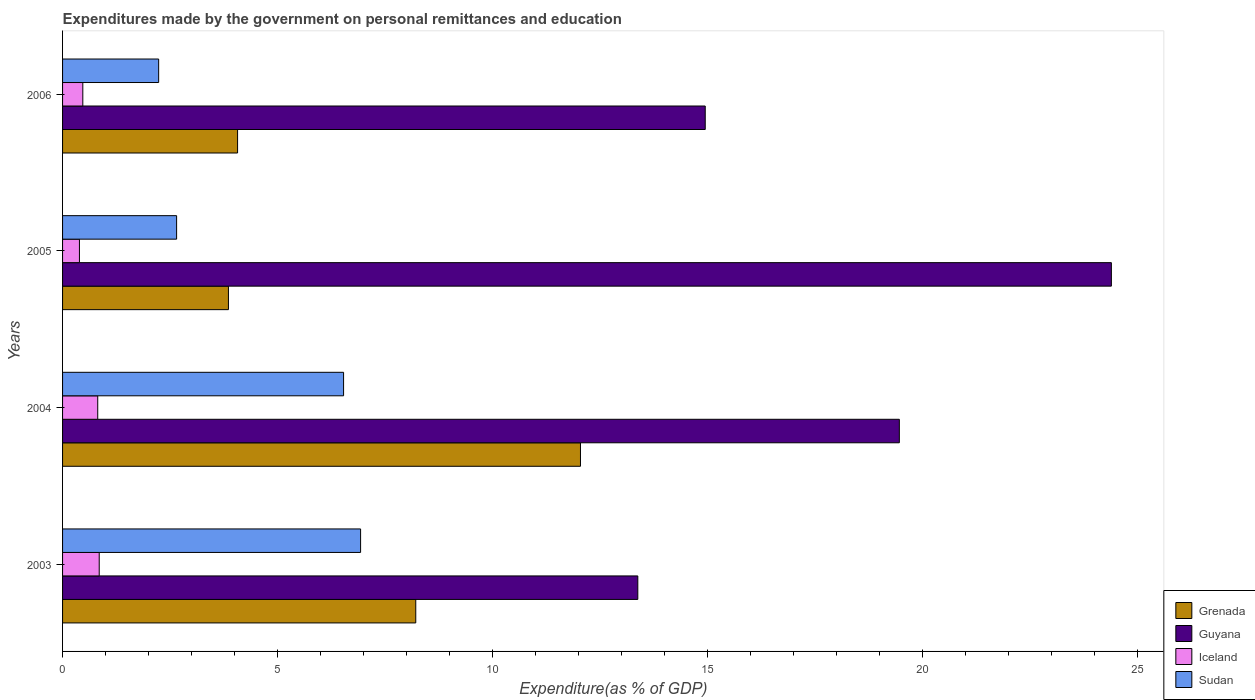How many bars are there on the 3rd tick from the top?
Provide a short and direct response. 4. How many bars are there on the 3rd tick from the bottom?
Keep it short and to the point. 4. In how many cases, is the number of bars for a given year not equal to the number of legend labels?
Offer a terse response. 0. What is the expenditures made by the government on personal remittances and education in Iceland in 2004?
Ensure brevity in your answer.  0.82. Across all years, what is the maximum expenditures made by the government on personal remittances and education in Guyana?
Provide a succinct answer. 24.4. Across all years, what is the minimum expenditures made by the government on personal remittances and education in Guyana?
Make the answer very short. 13.38. In which year was the expenditures made by the government on personal remittances and education in Guyana maximum?
Your response must be concise. 2005. What is the total expenditures made by the government on personal remittances and education in Grenada in the graph?
Provide a short and direct response. 28.2. What is the difference between the expenditures made by the government on personal remittances and education in Guyana in 2005 and that in 2006?
Make the answer very short. 9.45. What is the difference between the expenditures made by the government on personal remittances and education in Sudan in 2004 and the expenditures made by the government on personal remittances and education in Grenada in 2006?
Offer a very short reply. 2.47. What is the average expenditures made by the government on personal remittances and education in Sudan per year?
Ensure brevity in your answer.  4.59. In the year 2006, what is the difference between the expenditures made by the government on personal remittances and education in Grenada and expenditures made by the government on personal remittances and education in Sudan?
Provide a short and direct response. 1.84. What is the ratio of the expenditures made by the government on personal remittances and education in Grenada in 2004 to that in 2006?
Keep it short and to the point. 2.96. Is the expenditures made by the government on personal remittances and education in Iceland in 2003 less than that in 2004?
Ensure brevity in your answer.  No. What is the difference between the highest and the second highest expenditures made by the government on personal remittances and education in Iceland?
Make the answer very short. 0.03. What is the difference between the highest and the lowest expenditures made by the government on personal remittances and education in Iceland?
Keep it short and to the point. 0.46. Is it the case that in every year, the sum of the expenditures made by the government on personal remittances and education in Sudan and expenditures made by the government on personal remittances and education in Guyana is greater than the sum of expenditures made by the government on personal remittances and education in Grenada and expenditures made by the government on personal remittances and education in Iceland?
Offer a terse response. Yes. What does the 4th bar from the top in 2003 represents?
Offer a very short reply. Grenada. Is it the case that in every year, the sum of the expenditures made by the government on personal remittances and education in Guyana and expenditures made by the government on personal remittances and education in Sudan is greater than the expenditures made by the government on personal remittances and education in Iceland?
Provide a succinct answer. Yes. How many bars are there?
Provide a succinct answer. 16. How many years are there in the graph?
Offer a terse response. 4. What is the difference between two consecutive major ticks on the X-axis?
Your response must be concise. 5. Does the graph contain grids?
Keep it short and to the point. No. How many legend labels are there?
Your answer should be compact. 4. What is the title of the graph?
Give a very brief answer. Expenditures made by the government on personal remittances and education. What is the label or title of the X-axis?
Your response must be concise. Expenditure(as % of GDP). What is the Expenditure(as % of GDP) of Grenada in 2003?
Give a very brief answer. 8.22. What is the Expenditure(as % of GDP) of Guyana in 2003?
Keep it short and to the point. 13.38. What is the Expenditure(as % of GDP) in Iceland in 2003?
Your answer should be very brief. 0.85. What is the Expenditure(as % of GDP) in Sudan in 2003?
Your answer should be very brief. 6.93. What is the Expenditure(as % of GDP) in Grenada in 2004?
Keep it short and to the point. 12.05. What is the Expenditure(as % of GDP) in Guyana in 2004?
Provide a succinct answer. 19.47. What is the Expenditure(as % of GDP) of Iceland in 2004?
Make the answer very short. 0.82. What is the Expenditure(as % of GDP) of Sudan in 2004?
Make the answer very short. 6.54. What is the Expenditure(as % of GDP) in Grenada in 2005?
Give a very brief answer. 3.86. What is the Expenditure(as % of GDP) in Guyana in 2005?
Ensure brevity in your answer.  24.4. What is the Expenditure(as % of GDP) in Iceland in 2005?
Your response must be concise. 0.39. What is the Expenditure(as % of GDP) in Sudan in 2005?
Ensure brevity in your answer.  2.65. What is the Expenditure(as % of GDP) in Grenada in 2006?
Ensure brevity in your answer.  4.07. What is the Expenditure(as % of GDP) in Guyana in 2006?
Offer a very short reply. 14.95. What is the Expenditure(as % of GDP) of Iceland in 2006?
Your answer should be compact. 0.47. What is the Expenditure(as % of GDP) of Sudan in 2006?
Give a very brief answer. 2.24. Across all years, what is the maximum Expenditure(as % of GDP) of Grenada?
Make the answer very short. 12.05. Across all years, what is the maximum Expenditure(as % of GDP) in Guyana?
Give a very brief answer. 24.4. Across all years, what is the maximum Expenditure(as % of GDP) in Iceland?
Make the answer very short. 0.85. Across all years, what is the maximum Expenditure(as % of GDP) of Sudan?
Ensure brevity in your answer.  6.93. Across all years, what is the minimum Expenditure(as % of GDP) in Grenada?
Your response must be concise. 3.86. Across all years, what is the minimum Expenditure(as % of GDP) in Guyana?
Your answer should be compact. 13.38. Across all years, what is the minimum Expenditure(as % of GDP) of Iceland?
Your response must be concise. 0.39. Across all years, what is the minimum Expenditure(as % of GDP) in Sudan?
Provide a succinct answer. 2.24. What is the total Expenditure(as % of GDP) of Grenada in the graph?
Offer a very short reply. 28.2. What is the total Expenditure(as % of GDP) of Guyana in the graph?
Your answer should be very brief. 72.21. What is the total Expenditure(as % of GDP) of Iceland in the graph?
Keep it short and to the point. 2.53. What is the total Expenditure(as % of GDP) in Sudan in the graph?
Offer a terse response. 18.36. What is the difference between the Expenditure(as % of GDP) in Grenada in 2003 and that in 2004?
Offer a very short reply. -3.83. What is the difference between the Expenditure(as % of GDP) in Guyana in 2003 and that in 2004?
Your response must be concise. -6.08. What is the difference between the Expenditure(as % of GDP) of Iceland in 2003 and that in 2004?
Offer a terse response. 0.03. What is the difference between the Expenditure(as % of GDP) of Sudan in 2003 and that in 2004?
Your answer should be very brief. 0.4. What is the difference between the Expenditure(as % of GDP) of Grenada in 2003 and that in 2005?
Provide a short and direct response. 4.36. What is the difference between the Expenditure(as % of GDP) of Guyana in 2003 and that in 2005?
Make the answer very short. -11.02. What is the difference between the Expenditure(as % of GDP) of Iceland in 2003 and that in 2005?
Make the answer very short. 0.46. What is the difference between the Expenditure(as % of GDP) in Sudan in 2003 and that in 2005?
Your answer should be compact. 4.28. What is the difference between the Expenditure(as % of GDP) of Grenada in 2003 and that in 2006?
Provide a succinct answer. 4.15. What is the difference between the Expenditure(as % of GDP) in Guyana in 2003 and that in 2006?
Ensure brevity in your answer.  -1.57. What is the difference between the Expenditure(as % of GDP) in Iceland in 2003 and that in 2006?
Provide a short and direct response. 0.38. What is the difference between the Expenditure(as % of GDP) in Sudan in 2003 and that in 2006?
Provide a succinct answer. 4.7. What is the difference between the Expenditure(as % of GDP) of Grenada in 2004 and that in 2005?
Your answer should be very brief. 8.19. What is the difference between the Expenditure(as % of GDP) in Guyana in 2004 and that in 2005?
Provide a short and direct response. -4.93. What is the difference between the Expenditure(as % of GDP) of Iceland in 2004 and that in 2005?
Your response must be concise. 0.43. What is the difference between the Expenditure(as % of GDP) of Sudan in 2004 and that in 2005?
Provide a succinct answer. 3.88. What is the difference between the Expenditure(as % of GDP) of Grenada in 2004 and that in 2006?
Offer a very short reply. 7.98. What is the difference between the Expenditure(as % of GDP) in Guyana in 2004 and that in 2006?
Your response must be concise. 4.52. What is the difference between the Expenditure(as % of GDP) in Iceland in 2004 and that in 2006?
Make the answer very short. 0.35. What is the difference between the Expenditure(as % of GDP) in Sudan in 2004 and that in 2006?
Provide a succinct answer. 4.3. What is the difference between the Expenditure(as % of GDP) in Grenada in 2005 and that in 2006?
Give a very brief answer. -0.21. What is the difference between the Expenditure(as % of GDP) of Guyana in 2005 and that in 2006?
Offer a very short reply. 9.45. What is the difference between the Expenditure(as % of GDP) of Iceland in 2005 and that in 2006?
Your response must be concise. -0.08. What is the difference between the Expenditure(as % of GDP) of Sudan in 2005 and that in 2006?
Ensure brevity in your answer.  0.42. What is the difference between the Expenditure(as % of GDP) of Grenada in 2003 and the Expenditure(as % of GDP) of Guyana in 2004?
Ensure brevity in your answer.  -11.25. What is the difference between the Expenditure(as % of GDP) of Grenada in 2003 and the Expenditure(as % of GDP) of Iceland in 2004?
Your answer should be compact. 7.4. What is the difference between the Expenditure(as % of GDP) of Grenada in 2003 and the Expenditure(as % of GDP) of Sudan in 2004?
Give a very brief answer. 1.68. What is the difference between the Expenditure(as % of GDP) of Guyana in 2003 and the Expenditure(as % of GDP) of Iceland in 2004?
Your response must be concise. 12.57. What is the difference between the Expenditure(as % of GDP) of Guyana in 2003 and the Expenditure(as % of GDP) of Sudan in 2004?
Make the answer very short. 6.85. What is the difference between the Expenditure(as % of GDP) in Iceland in 2003 and the Expenditure(as % of GDP) in Sudan in 2004?
Provide a succinct answer. -5.69. What is the difference between the Expenditure(as % of GDP) in Grenada in 2003 and the Expenditure(as % of GDP) in Guyana in 2005?
Make the answer very short. -16.18. What is the difference between the Expenditure(as % of GDP) of Grenada in 2003 and the Expenditure(as % of GDP) of Iceland in 2005?
Your response must be concise. 7.83. What is the difference between the Expenditure(as % of GDP) of Grenada in 2003 and the Expenditure(as % of GDP) of Sudan in 2005?
Provide a succinct answer. 5.56. What is the difference between the Expenditure(as % of GDP) in Guyana in 2003 and the Expenditure(as % of GDP) in Iceland in 2005?
Keep it short and to the point. 12.99. What is the difference between the Expenditure(as % of GDP) of Guyana in 2003 and the Expenditure(as % of GDP) of Sudan in 2005?
Your response must be concise. 10.73. What is the difference between the Expenditure(as % of GDP) in Iceland in 2003 and the Expenditure(as % of GDP) in Sudan in 2005?
Ensure brevity in your answer.  -1.8. What is the difference between the Expenditure(as % of GDP) in Grenada in 2003 and the Expenditure(as % of GDP) in Guyana in 2006?
Your answer should be compact. -6.74. What is the difference between the Expenditure(as % of GDP) of Grenada in 2003 and the Expenditure(as % of GDP) of Iceland in 2006?
Offer a terse response. 7.75. What is the difference between the Expenditure(as % of GDP) in Grenada in 2003 and the Expenditure(as % of GDP) in Sudan in 2006?
Your answer should be very brief. 5.98. What is the difference between the Expenditure(as % of GDP) in Guyana in 2003 and the Expenditure(as % of GDP) in Iceland in 2006?
Make the answer very short. 12.91. What is the difference between the Expenditure(as % of GDP) of Guyana in 2003 and the Expenditure(as % of GDP) of Sudan in 2006?
Your response must be concise. 11.15. What is the difference between the Expenditure(as % of GDP) in Iceland in 2003 and the Expenditure(as % of GDP) in Sudan in 2006?
Keep it short and to the point. -1.38. What is the difference between the Expenditure(as % of GDP) of Grenada in 2004 and the Expenditure(as % of GDP) of Guyana in 2005?
Ensure brevity in your answer.  -12.35. What is the difference between the Expenditure(as % of GDP) in Grenada in 2004 and the Expenditure(as % of GDP) in Iceland in 2005?
Your answer should be compact. 11.66. What is the difference between the Expenditure(as % of GDP) in Grenada in 2004 and the Expenditure(as % of GDP) in Sudan in 2005?
Ensure brevity in your answer.  9.4. What is the difference between the Expenditure(as % of GDP) of Guyana in 2004 and the Expenditure(as % of GDP) of Iceland in 2005?
Your answer should be very brief. 19.08. What is the difference between the Expenditure(as % of GDP) in Guyana in 2004 and the Expenditure(as % of GDP) in Sudan in 2005?
Give a very brief answer. 16.82. What is the difference between the Expenditure(as % of GDP) in Iceland in 2004 and the Expenditure(as % of GDP) in Sudan in 2005?
Your response must be concise. -1.84. What is the difference between the Expenditure(as % of GDP) of Grenada in 2004 and the Expenditure(as % of GDP) of Guyana in 2006?
Provide a succinct answer. -2.9. What is the difference between the Expenditure(as % of GDP) in Grenada in 2004 and the Expenditure(as % of GDP) in Iceland in 2006?
Offer a terse response. 11.58. What is the difference between the Expenditure(as % of GDP) in Grenada in 2004 and the Expenditure(as % of GDP) in Sudan in 2006?
Your response must be concise. 9.81. What is the difference between the Expenditure(as % of GDP) of Guyana in 2004 and the Expenditure(as % of GDP) of Iceland in 2006?
Provide a short and direct response. 19. What is the difference between the Expenditure(as % of GDP) of Guyana in 2004 and the Expenditure(as % of GDP) of Sudan in 2006?
Give a very brief answer. 17.23. What is the difference between the Expenditure(as % of GDP) of Iceland in 2004 and the Expenditure(as % of GDP) of Sudan in 2006?
Provide a succinct answer. -1.42. What is the difference between the Expenditure(as % of GDP) in Grenada in 2005 and the Expenditure(as % of GDP) in Guyana in 2006?
Provide a succinct answer. -11.09. What is the difference between the Expenditure(as % of GDP) in Grenada in 2005 and the Expenditure(as % of GDP) in Iceland in 2006?
Ensure brevity in your answer.  3.39. What is the difference between the Expenditure(as % of GDP) in Grenada in 2005 and the Expenditure(as % of GDP) in Sudan in 2006?
Provide a succinct answer. 1.62. What is the difference between the Expenditure(as % of GDP) in Guyana in 2005 and the Expenditure(as % of GDP) in Iceland in 2006?
Offer a very short reply. 23.93. What is the difference between the Expenditure(as % of GDP) of Guyana in 2005 and the Expenditure(as % of GDP) of Sudan in 2006?
Provide a succinct answer. 22.17. What is the difference between the Expenditure(as % of GDP) in Iceland in 2005 and the Expenditure(as % of GDP) in Sudan in 2006?
Give a very brief answer. -1.84. What is the average Expenditure(as % of GDP) in Grenada per year?
Provide a short and direct response. 7.05. What is the average Expenditure(as % of GDP) of Guyana per year?
Keep it short and to the point. 18.05. What is the average Expenditure(as % of GDP) of Iceland per year?
Your response must be concise. 0.63. What is the average Expenditure(as % of GDP) of Sudan per year?
Provide a short and direct response. 4.59. In the year 2003, what is the difference between the Expenditure(as % of GDP) in Grenada and Expenditure(as % of GDP) in Guyana?
Provide a short and direct response. -5.17. In the year 2003, what is the difference between the Expenditure(as % of GDP) of Grenada and Expenditure(as % of GDP) of Iceland?
Offer a terse response. 7.36. In the year 2003, what is the difference between the Expenditure(as % of GDP) of Grenada and Expenditure(as % of GDP) of Sudan?
Offer a very short reply. 1.28. In the year 2003, what is the difference between the Expenditure(as % of GDP) in Guyana and Expenditure(as % of GDP) in Iceland?
Your response must be concise. 12.53. In the year 2003, what is the difference between the Expenditure(as % of GDP) of Guyana and Expenditure(as % of GDP) of Sudan?
Your answer should be compact. 6.45. In the year 2003, what is the difference between the Expenditure(as % of GDP) in Iceland and Expenditure(as % of GDP) in Sudan?
Ensure brevity in your answer.  -6.08. In the year 2004, what is the difference between the Expenditure(as % of GDP) of Grenada and Expenditure(as % of GDP) of Guyana?
Offer a very short reply. -7.42. In the year 2004, what is the difference between the Expenditure(as % of GDP) of Grenada and Expenditure(as % of GDP) of Iceland?
Your response must be concise. 11.23. In the year 2004, what is the difference between the Expenditure(as % of GDP) in Grenada and Expenditure(as % of GDP) in Sudan?
Offer a terse response. 5.51. In the year 2004, what is the difference between the Expenditure(as % of GDP) of Guyana and Expenditure(as % of GDP) of Iceland?
Keep it short and to the point. 18.65. In the year 2004, what is the difference between the Expenditure(as % of GDP) of Guyana and Expenditure(as % of GDP) of Sudan?
Ensure brevity in your answer.  12.93. In the year 2004, what is the difference between the Expenditure(as % of GDP) in Iceland and Expenditure(as % of GDP) in Sudan?
Provide a succinct answer. -5.72. In the year 2005, what is the difference between the Expenditure(as % of GDP) in Grenada and Expenditure(as % of GDP) in Guyana?
Ensure brevity in your answer.  -20.54. In the year 2005, what is the difference between the Expenditure(as % of GDP) in Grenada and Expenditure(as % of GDP) in Iceland?
Offer a very short reply. 3.47. In the year 2005, what is the difference between the Expenditure(as % of GDP) in Grenada and Expenditure(as % of GDP) in Sudan?
Make the answer very short. 1.21. In the year 2005, what is the difference between the Expenditure(as % of GDP) in Guyana and Expenditure(as % of GDP) in Iceland?
Keep it short and to the point. 24.01. In the year 2005, what is the difference between the Expenditure(as % of GDP) in Guyana and Expenditure(as % of GDP) in Sudan?
Your answer should be compact. 21.75. In the year 2005, what is the difference between the Expenditure(as % of GDP) of Iceland and Expenditure(as % of GDP) of Sudan?
Offer a very short reply. -2.26. In the year 2006, what is the difference between the Expenditure(as % of GDP) of Grenada and Expenditure(as % of GDP) of Guyana?
Ensure brevity in your answer.  -10.88. In the year 2006, what is the difference between the Expenditure(as % of GDP) in Grenada and Expenditure(as % of GDP) in Iceland?
Your answer should be compact. 3.6. In the year 2006, what is the difference between the Expenditure(as % of GDP) of Grenada and Expenditure(as % of GDP) of Sudan?
Keep it short and to the point. 1.84. In the year 2006, what is the difference between the Expenditure(as % of GDP) in Guyana and Expenditure(as % of GDP) in Iceland?
Provide a succinct answer. 14.48. In the year 2006, what is the difference between the Expenditure(as % of GDP) in Guyana and Expenditure(as % of GDP) in Sudan?
Your answer should be compact. 12.72. In the year 2006, what is the difference between the Expenditure(as % of GDP) of Iceland and Expenditure(as % of GDP) of Sudan?
Keep it short and to the point. -1.76. What is the ratio of the Expenditure(as % of GDP) of Grenada in 2003 to that in 2004?
Ensure brevity in your answer.  0.68. What is the ratio of the Expenditure(as % of GDP) of Guyana in 2003 to that in 2004?
Offer a very short reply. 0.69. What is the ratio of the Expenditure(as % of GDP) in Iceland in 2003 to that in 2004?
Your response must be concise. 1.04. What is the ratio of the Expenditure(as % of GDP) in Sudan in 2003 to that in 2004?
Ensure brevity in your answer.  1.06. What is the ratio of the Expenditure(as % of GDP) of Grenada in 2003 to that in 2005?
Offer a very short reply. 2.13. What is the ratio of the Expenditure(as % of GDP) of Guyana in 2003 to that in 2005?
Ensure brevity in your answer.  0.55. What is the ratio of the Expenditure(as % of GDP) of Iceland in 2003 to that in 2005?
Give a very brief answer. 2.17. What is the ratio of the Expenditure(as % of GDP) in Sudan in 2003 to that in 2005?
Offer a terse response. 2.61. What is the ratio of the Expenditure(as % of GDP) of Grenada in 2003 to that in 2006?
Offer a terse response. 2.02. What is the ratio of the Expenditure(as % of GDP) in Guyana in 2003 to that in 2006?
Provide a succinct answer. 0.9. What is the ratio of the Expenditure(as % of GDP) of Iceland in 2003 to that in 2006?
Ensure brevity in your answer.  1.81. What is the ratio of the Expenditure(as % of GDP) of Sudan in 2003 to that in 2006?
Provide a short and direct response. 3.1. What is the ratio of the Expenditure(as % of GDP) in Grenada in 2004 to that in 2005?
Provide a succinct answer. 3.12. What is the ratio of the Expenditure(as % of GDP) of Guyana in 2004 to that in 2005?
Ensure brevity in your answer.  0.8. What is the ratio of the Expenditure(as % of GDP) in Iceland in 2004 to that in 2005?
Provide a succinct answer. 2.08. What is the ratio of the Expenditure(as % of GDP) of Sudan in 2004 to that in 2005?
Offer a very short reply. 2.46. What is the ratio of the Expenditure(as % of GDP) in Grenada in 2004 to that in 2006?
Your answer should be compact. 2.96. What is the ratio of the Expenditure(as % of GDP) of Guyana in 2004 to that in 2006?
Provide a short and direct response. 1.3. What is the ratio of the Expenditure(as % of GDP) in Iceland in 2004 to that in 2006?
Ensure brevity in your answer.  1.74. What is the ratio of the Expenditure(as % of GDP) in Sudan in 2004 to that in 2006?
Your answer should be very brief. 2.92. What is the ratio of the Expenditure(as % of GDP) in Grenada in 2005 to that in 2006?
Your answer should be very brief. 0.95. What is the ratio of the Expenditure(as % of GDP) of Guyana in 2005 to that in 2006?
Keep it short and to the point. 1.63. What is the ratio of the Expenditure(as % of GDP) in Iceland in 2005 to that in 2006?
Your response must be concise. 0.83. What is the ratio of the Expenditure(as % of GDP) of Sudan in 2005 to that in 2006?
Make the answer very short. 1.19. What is the difference between the highest and the second highest Expenditure(as % of GDP) in Grenada?
Your answer should be compact. 3.83. What is the difference between the highest and the second highest Expenditure(as % of GDP) of Guyana?
Provide a short and direct response. 4.93. What is the difference between the highest and the second highest Expenditure(as % of GDP) of Iceland?
Your response must be concise. 0.03. What is the difference between the highest and the second highest Expenditure(as % of GDP) in Sudan?
Offer a very short reply. 0.4. What is the difference between the highest and the lowest Expenditure(as % of GDP) of Grenada?
Ensure brevity in your answer.  8.19. What is the difference between the highest and the lowest Expenditure(as % of GDP) in Guyana?
Provide a short and direct response. 11.02. What is the difference between the highest and the lowest Expenditure(as % of GDP) of Iceland?
Provide a short and direct response. 0.46. What is the difference between the highest and the lowest Expenditure(as % of GDP) in Sudan?
Your response must be concise. 4.7. 